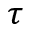<formula> <loc_0><loc_0><loc_500><loc_500>\tau</formula> 